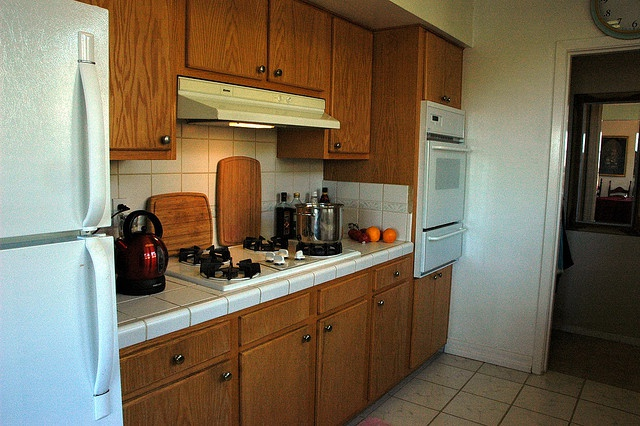Describe the objects in this image and their specific colors. I can see refrigerator in darkgray, lightblue, beige, and lightgray tones, oven in darkgray and gray tones, bowl in darkgray, black, gray, and maroon tones, clock in darkgray, black, and darkgreen tones, and bottle in darkgray, black, gray, and maroon tones in this image. 